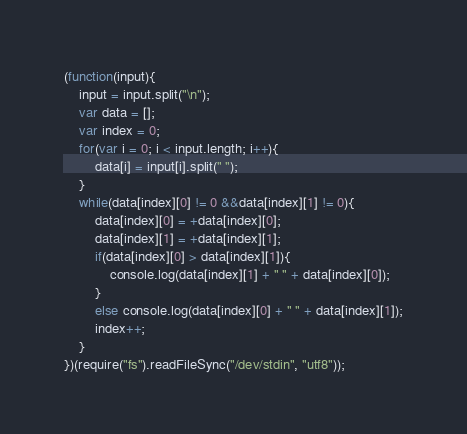<code> <loc_0><loc_0><loc_500><loc_500><_JavaScript_>(function(input){
	input = input.split("\n");
	var data = [];
	var index = 0;
	for(var i = 0; i < input.length; i++){
		data[i] = input[i].split(" ");
	}
	while(data[index][0] != 0 &&data[index][1] != 0){
		data[index][0] = +data[index][0];
		data[index][1] = +data[index][1];
		if(data[index][0] > data[index][1]){
			console.log(data[index][1] + " " + data[index][0]);
		}
		else console.log(data[index][0] + " " + data[index][1]);
		index++;
	}
})(require("fs").readFileSync("/dev/stdin", "utf8"));</code> 